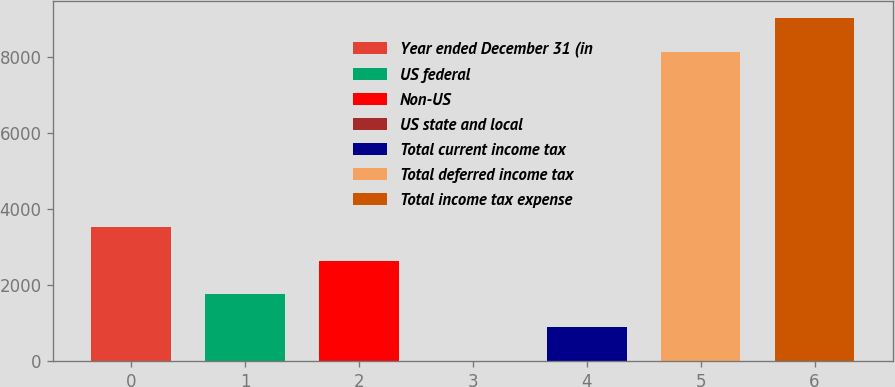Convert chart to OTSL. <chart><loc_0><loc_0><loc_500><loc_500><bar_chart><fcel>Year ended December 31 (in<fcel>US federal<fcel>Non-US<fcel>US state and local<fcel>Total current income tax<fcel>Total deferred income tax<fcel>Total income tax expense<nl><fcel>3518<fcel>1761<fcel>2639.5<fcel>4<fcel>882.5<fcel>8139<fcel>9017.5<nl></chart> 